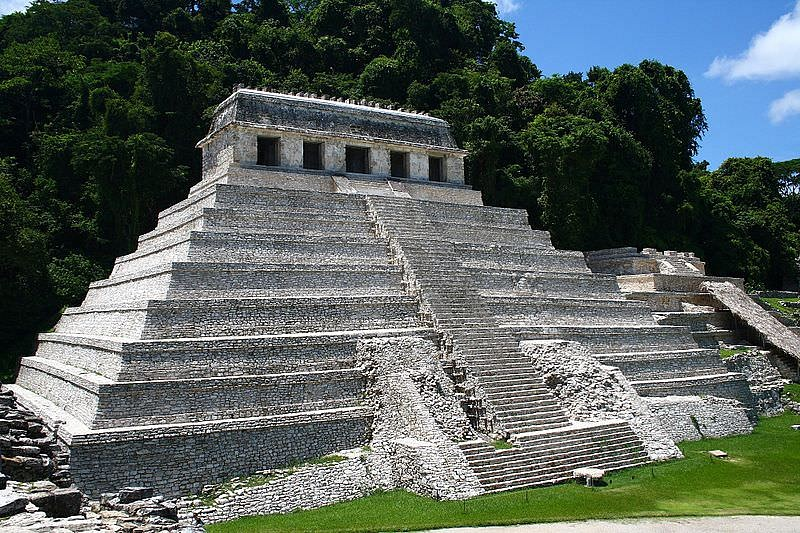In the context of ancient Mayan civilization, how did such structures contribute to their society? In the context of ancient Mayan civilization, structures like the Temple of the Inscriptions played a crucial role in societal development and cohesion. These edifices served as focal points for religious activities, where elaborate ceremonies and rituals were conducted to honor their gods and seek divine favor, thereby reinforcing the spiritual and cultural identity of the community. Such temples also functioned as tombs for revered leaders, which underscored the divine status of the rulers and legitimized their authority. The construction of these monumental structures demonstrated the technological and engineering prowess of the Mayans, showcasing their ability to organize labor and resources effectively. Furthermore, the temples acted as astronomical observatories, allowing the Mayans to develop sophisticated calendars and enhance their agricultural practices. These multifaceted roles of the structures fostered a strong sense of unity, knowledge, and progress within Mayan society.  How would you describe this image to someone who cannot see it? To describe this image to someone who cannot see it, imagine a towering structure made of gray stone, standing majestically against a backdrop of dense, lush green jungle. The structure is a massive pyramid with steep, tiered steps that ascend sharply to a temple at the very top. This temple, with its white walls and red roof, contrasts vividly with the stone pyramid and the surrounding greenery. The overall scene conveys a sense of ancient grandeur and harmony with nature. The pyramid's imposing height and architectural refinement reflect the advanced skills and cultural richness of the Mayan civilization. The greenery surrounding the pyramid adds a vibrant, natural beauty to the scene, highlighting the coexistence of human ingenuity and the natural world. 